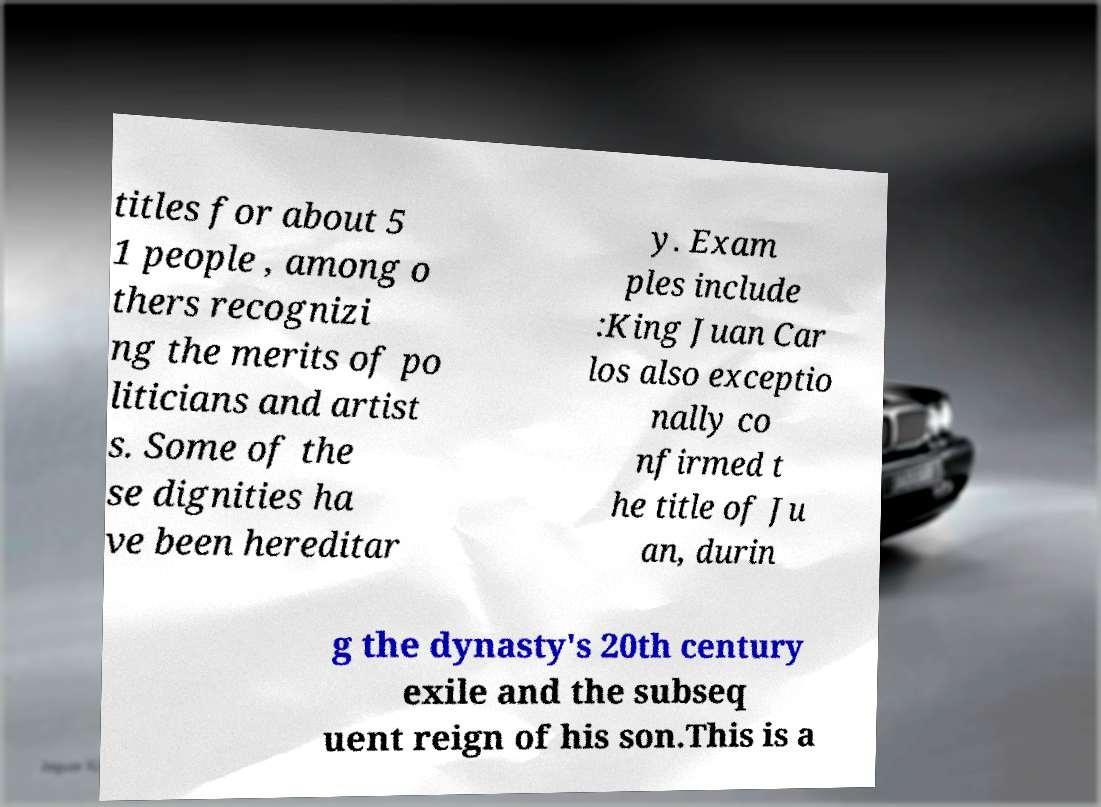Could you extract and type out the text from this image? titles for about 5 1 people , among o thers recognizi ng the merits of po liticians and artist s. Some of the se dignities ha ve been hereditar y. Exam ples include :King Juan Car los also exceptio nally co nfirmed t he title of Ju an, durin g the dynasty's 20th century exile and the subseq uent reign of his son.This is a 